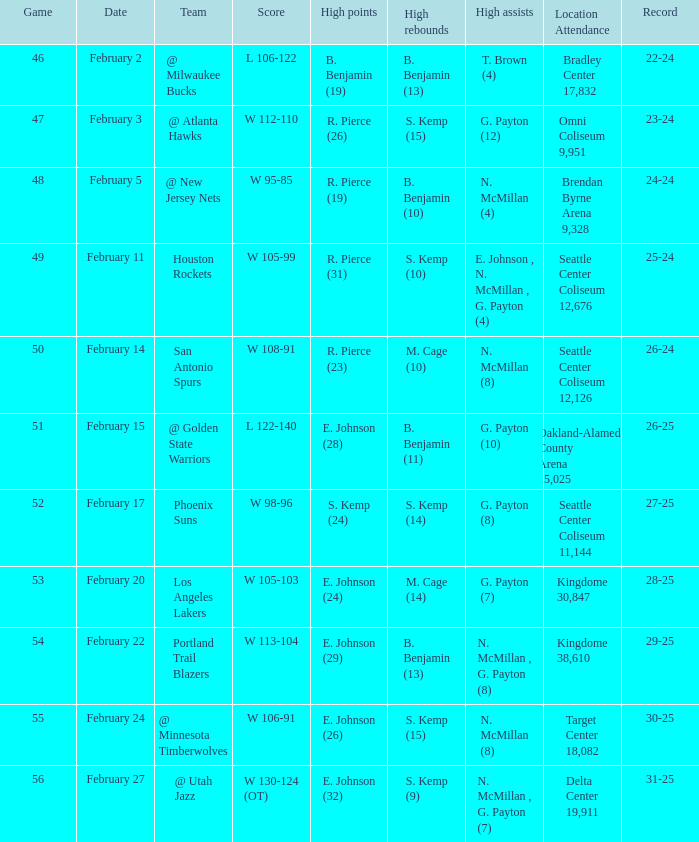Can you provide the location and number of attendees for the game in which b. benjamin (10) achieved the highest rebounds? Brendan Byrne Arena 9,328. 